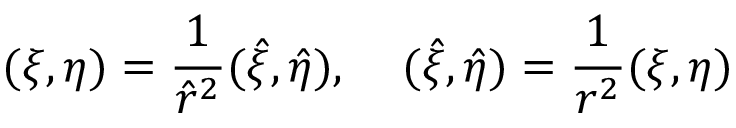Convert formula to latex. <formula><loc_0><loc_0><loc_500><loc_500>( \xi , \eta ) = \frac { 1 } { \hat { r } ^ { 2 } } ( \hat { \xi } , \hat { \eta } ) , \, ( \hat { \xi } , \hat { \eta } ) = \frac { 1 } { r ^ { 2 } } ( \xi , \eta )</formula> 